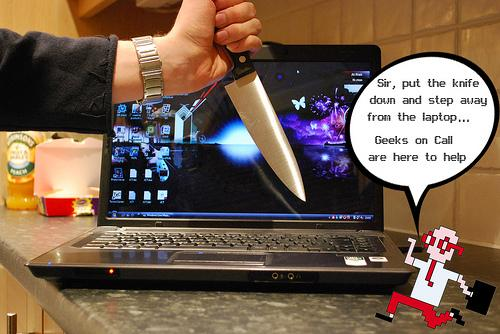Provide a brief overview of the primary elements in the image. The image features a person holding a knife, a laptop on the counter, a bottle, a watch on the wrist, and a cartoon character in the scene. Mention two objects in proximity to each other and explain their positions. A hand holding a knife is next to a person wearing a silver watchband, with the knife pointing downwards and the watch on their wrist. Explain what the cartoon character in the image is doing or saying. The cartoon character in the image has an accompanying quote bubble, implying that they are speaking or expressing a thought. Illuminate the small details seen in any object within the image. The watch on the person's wrist has a silver band and features a small butterfly on its screen. Point out an object with a notable color and briefly explain it. The gray stone color on the table top adds an interesting texture and visual element to the image. In a single sentence, list three different objects that can be found in the image. The image consists of a hand holding a knife, a laptop on a counter, and a cartoon character with a quote bubble. Describe the appearance of the knife and its holder in the image. In the image, a hand gripping a knife handle holds a long silver knife blade with a black edge and a small silver bolt. Mention the central electronic device in the image and state its components. The laptop on the counter is the central electronic device, featuring an LCD screen, keyboard, touchpad, and power light. Identify and describe the primary object on the left side of the image. There is a hand holding a knife with the blade pointing downwards, featuring a silver tip and black edge. Explain what the most notable object in the image is and describe its characteristics. The most notable object in the image is a laptop on the counter, with visible elements including the LCD screen, keyboard, touchpad, and a blue line across the screen. 